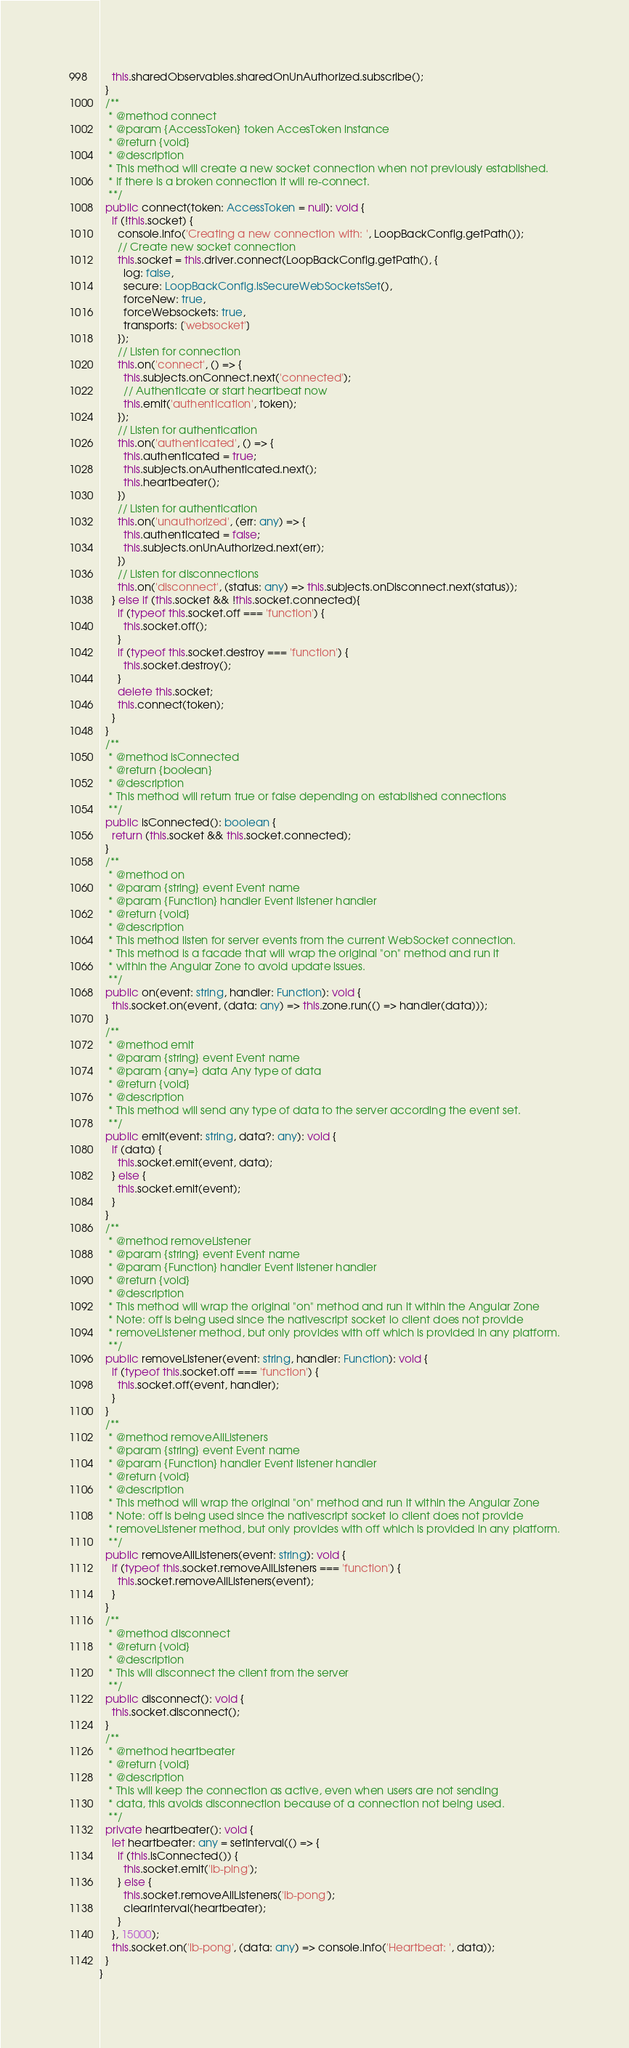<code> <loc_0><loc_0><loc_500><loc_500><_TypeScript_>    this.sharedObservables.sharedOnUnAuthorized.subscribe();
  }
  /**
   * @method connect
   * @param {AccessToken} token AccesToken instance
   * @return {void}
   * @description
   * This method will create a new socket connection when not previously established.
   * If there is a broken connection it will re-connect.
   **/
  public connect(token: AccessToken = null): void {
    if (!this.socket) {
      console.info('Creating a new connection with: ', LoopBackConfig.getPath());
      // Create new socket connection
      this.socket = this.driver.connect(LoopBackConfig.getPath(), {
        log: false,
        secure: LoopBackConfig.isSecureWebSocketsSet(),
        forceNew: true,
        forceWebsockets: true,
        transports: ['websocket']
      });
      // Listen for connection
      this.on('connect', () => {
        this.subjects.onConnect.next('connected');
        // Authenticate or start heartbeat now    
        this.emit('authentication', token);
      });
      // Listen for authentication
      this.on('authenticated', () => {
        this.authenticated = true;
        this.subjects.onAuthenticated.next();
        this.heartbeater();
      })
      // Listen for authentication
      this.on('unauthorized', (err: any) => {
        this.authenticated = false;
        this.subjects.onUnAuthorized.next(err);
      })
      // Listen for disconnections
      this.on('disconnect', (status: any) => this.subjects.onDisconnect.next(status));
    } else if (this.socket && !this.socket.connected){
      if (typeof this.socket.off === 'function') {
        this.socket.off();
      }
      if (typeof this.socket.destroy === 'function') {
        this.socket.destroy();
      }
      delete this.socket;
      this.connect(token);
    }
  }
  /**
   * @method isConnected
   * @return {boolean}
   * @description
   * This method will return true or false depending on established connections
   **/
  public isConnected(): boolean {
    return (this.socket && this.socket.connected);
  }
  /**
   * @method on
   * @param {string} event Event name
   * @param {Function} handler Event listener handler
   * @return {void}
   * @description
   * This method listen for server events from the current WebSocket connection.
   * This method is a facade that will wrap the original "on" method and run it
   * within the Angular Zone to avoid update issues.
   **/
  public on(event: string, handler: Function): void {
    this.socket.on(event, (data: any) => this.zone.run(() => handler(data)));
  }
  /**
   * @method emit
   * @param {string} event Event name
   * @param {any=} data Any type of data
   * @return {void}
   * @description
   * This method will send any type of data to the server according the event set.
   **/
  public emit(event: string, data?: any): void {
    if (data) {
      this.socket.emit(event, data);
    } else {
      this.socket.emit(event);
    }
  }
  /**
   * @method removeListener
   * @param {string} event Event name
   * @param {Function} handler Event listener handler
   * @return {void}
   * @description
   * This method will wrap the original "on" method and run it within the Angular Zone
   * Note: off is being used since the nativescript socket io client does not provide
   * removeListener method, but only provides with off which is provided in any platform.
   **/
  public removeListener(event: string, handler: Function): void {
    if (typeof this.socket.off === 'function') {
      this.socket.off(event, handler);
    }
  }
  /**
   * @method removeAllListeners
   * @param {string} event Event name
   * @param {Function} handler Event listener handler
   * @return {void}
   * @description
   * This method will wrap the original "on" method and run it within the Angular Zone
   * Note: off is being used since the nativescript socket io client does not provide
   * removeListener method, but only provides with off which is provided in any platform.
   **/
  public removeAllListeners(event: string): void {
    if (typeof this.socket.removeAllListeners === 'function') {
      this.socket.removeAllListeners(event);
    }
  }
  /**
   * @method disconnect
   * @return {void}
   * @description
   * This will disconnect the client from the server
   **/
  public disconnect(): void {
    this.socket.disconnect();
  }
  /**
   * @method heartbeater
   * @return {void}
   * @description
   * This will keep the connection as active, even when users are not sending
   * data, this avoids disconnection because of a connection not being used.
   **/
  private heartbeater(): void {
    let heartbeater: any = setInterval(() => {
      if (this.isConnected()) {
        this.socket.emit('lb-ping');
      } else {
        this.socket.removeAllListeners('lb-pong');
        clearInterval(heartbeater);
      }
    }, 15000);
    this.socket.on('lb-pong', (data: any) => console.info('Heartbeat: ', data));
  }
}
</code> 